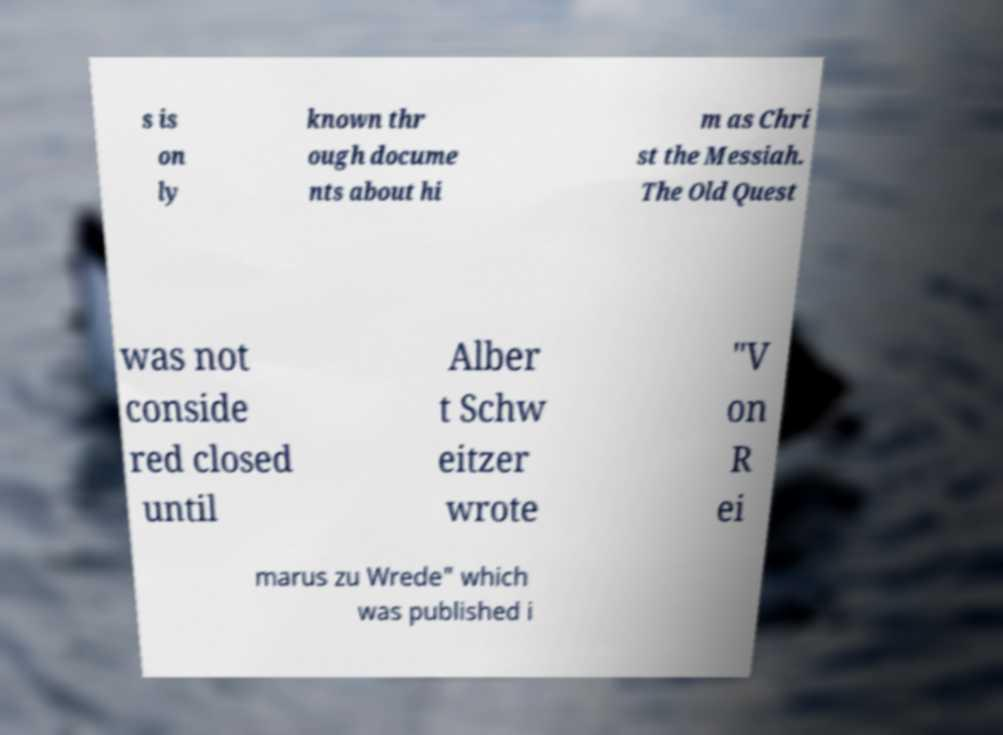For documentation purposes, I need the text within this image transcribed. Could you provide that? s is on ly known thr ough docume nts about hi m as Chri st the Messiah. The Old Quest was not conside red closed until Alber t Schw eitzer wrote "V on R ei marus zu Wrede" which was published i 